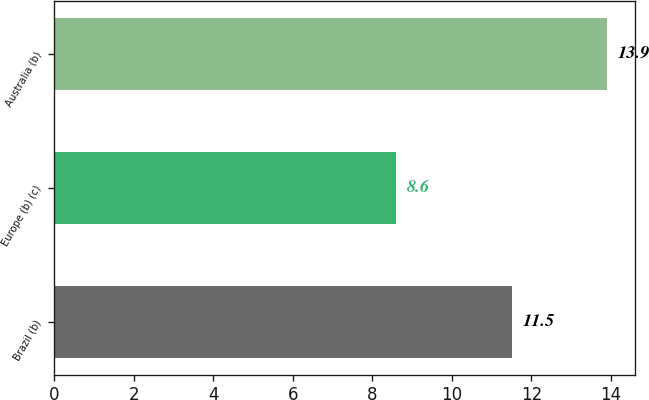<chart> <loc_0><loc_0><loc_500><loc_500><bar_chart><fcel>Brazil (b)<fcel>Europe (b) (c)<fcel>Australia (b)<nl><fcel>11.5<fcel>8.6<fcel>13.9<nl></chart> 